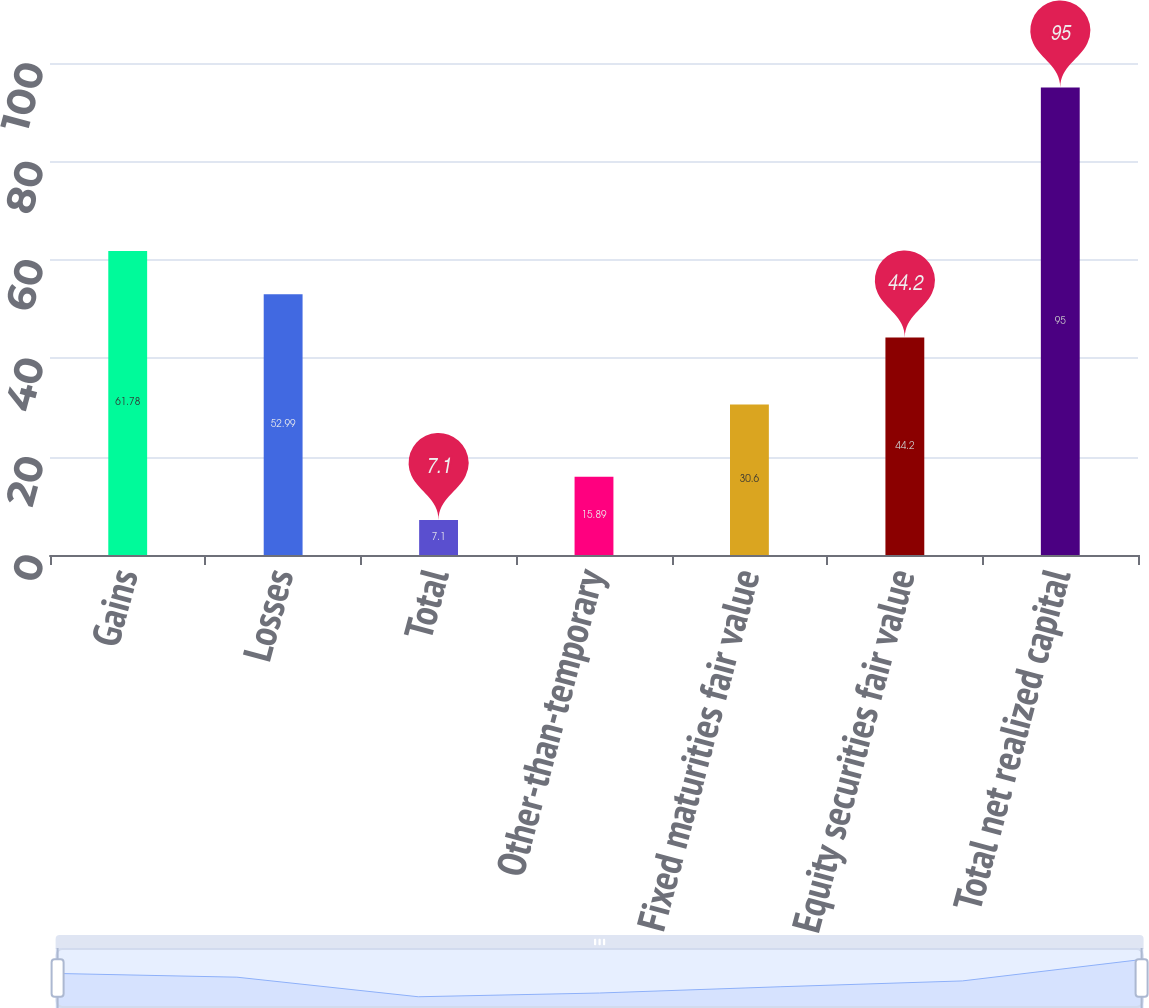Convert chart. <chart><loc_0><loc_0><loc_500><loc_500><bar_chart><fcel>Gains<fcel>Losses<fcel>Total<fcel>Other-than-temporary<fcel>Fixed maturities fair value<fcel>Equity securities fair value<fcel>Total net realized capital<nl><fcel>61.78<fcel>52.99<fcel>7.1<fcel>15.89<fcel>30.6<fcel>44.2<fcel>95<nl></chart> 